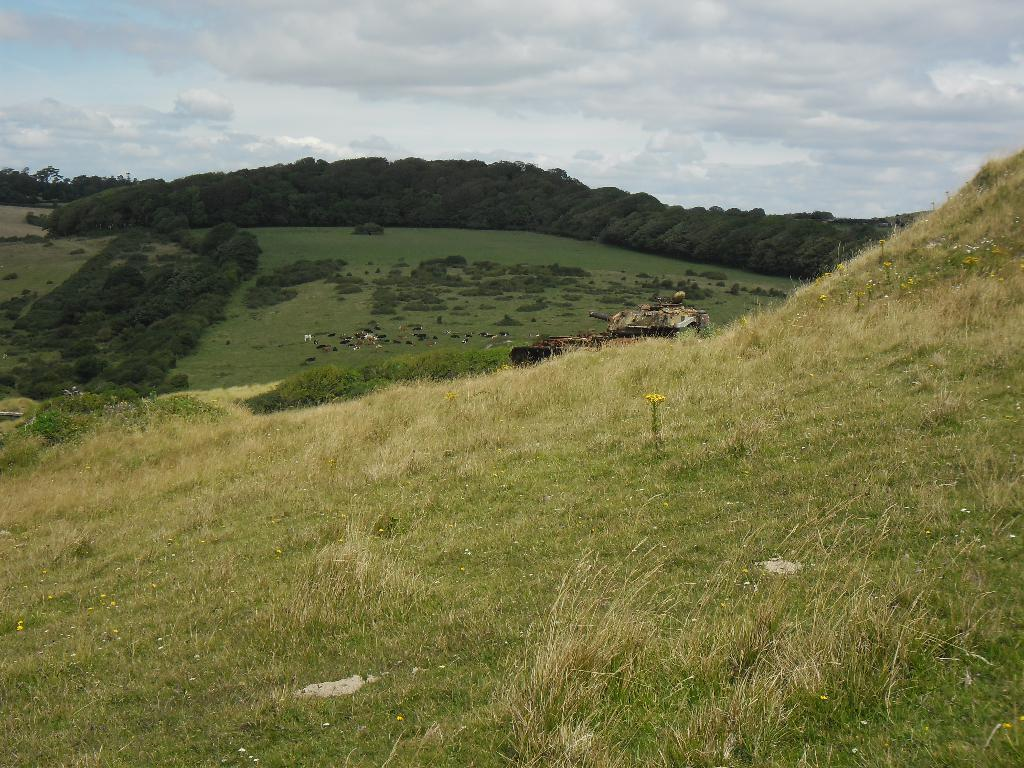What type of vegetation is at the bottom of the image? There is grass at the bottom of the image. What can be seen in the background of the image? There are trees in the background of the image. What type of living organisms are present in the image? Animals are present in the image. What is visible at the top of the image? The sky is visible at the top of the image. How many secretaries are present in the image? There are no secretaries present in the image. What type of snake can be seen slithering through the grass in the image? There is no snake present in the image; it features grass, trees, animals, and the sky. 